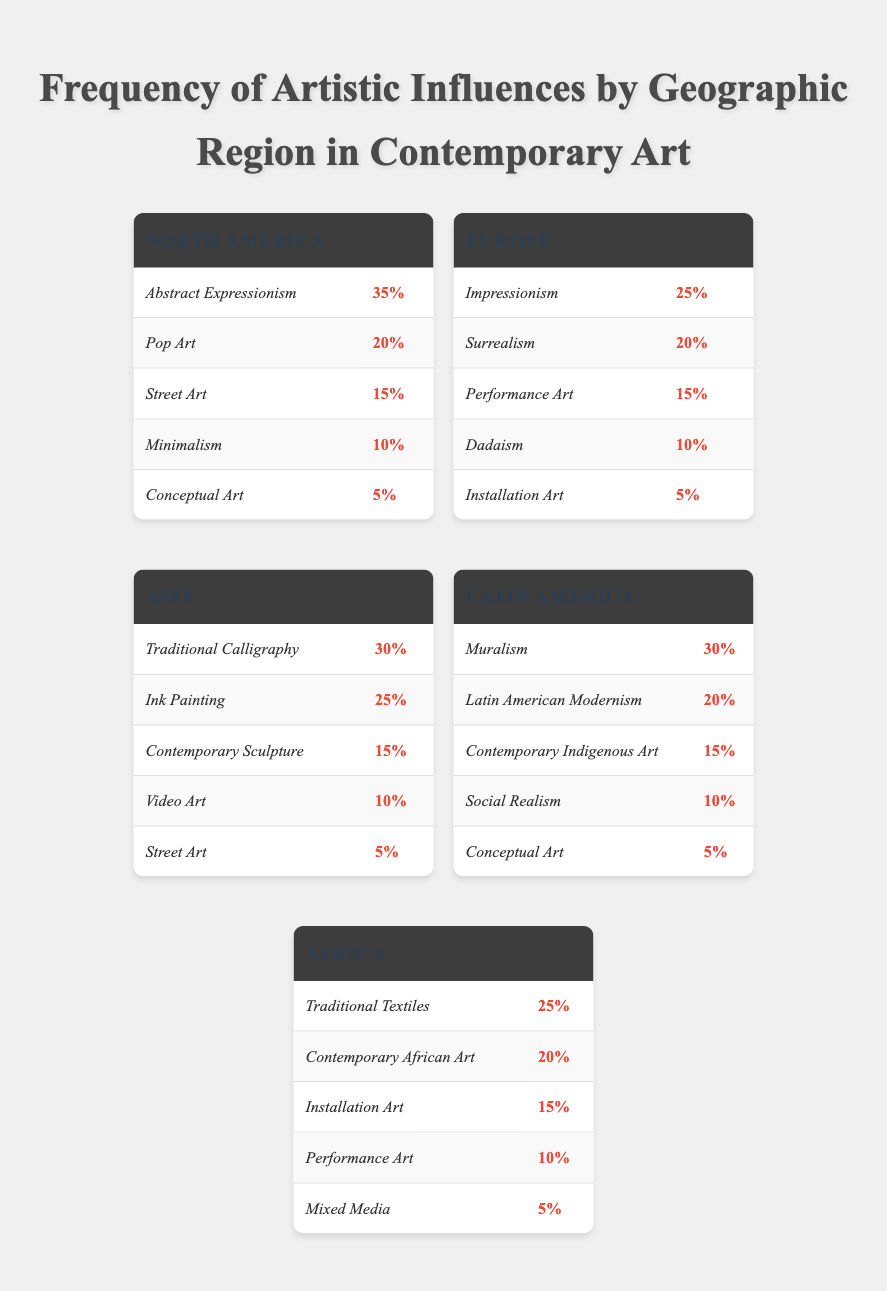What is the most prominent artistic influence in North America? From the data, North America shows a frequency of 35% for Abstract Expressionism, making it the highest percentage compared to other influences in the region.
Answer: Abstract Expressionism How many artistic influences are listed for Asia? In Asia, there are five influences provided: Traditional Calligraphy, Ink Painting, Contemporary Sculpture, Video Art, and Street Art. Therefore, the total count is five.
Answer: 5 Which region has the highest frequency for Performance Art? In the data for Europe, Performance Art is recorded at 15%. Other regions either list it with a lower frequency or do not mention it at all. Thus, Europe holds the highest frequency for this influence.
Answer: Europe What is the combined frequency of Muralism and Latin American Modernism in Latin America? The frequency of Muralism is 30% and Latin American Modernism is 20%. Adding these together gives 30 + 20 = 50%.
Answer: 50% Is the statement true that Africa has higher frequencies for Installation Art than North America? In Africa, the frequency for Installation Art is 15%, while North America has it at 10%. Since 15% is greater than 10%, the statement is true.
Answer: True What artistic influence in Asia has the lowest frequency? From the listed influences in Asia, Street Art is recorded at 5%, which is the lowest compared to the others.
Answer: Street Art What is the average frequency of artistic influences in Europe? Europe has five influences, with frequencies of 25, 20, 15, 10, and 5. To find the average, sum these (25 + 20 + 15 + 10 + 5 = 75) and divide by 5, resulting in an average of 75/5 = 15.
Answer: 15 In which geographic region is Conceptual Art featured, and what is its frequency? Conceptual Art is featured in both North America and Latin America with frequencies of 5% for each. Thus, it exists in both regions, and the frequency is 5%.
Answer: North America and Latin America; 5% Which artistic influence has the second-highest frequency in North America? The frequencies listed for North America are: Abstract Expressionism (35%), Pop Art (20%), Street Art (15%), Minimalism (10%), and Conceptual Art (5%). Therefore, Pop Art, with a frequency of 20%, ranks second.
Answer: Pop Art 